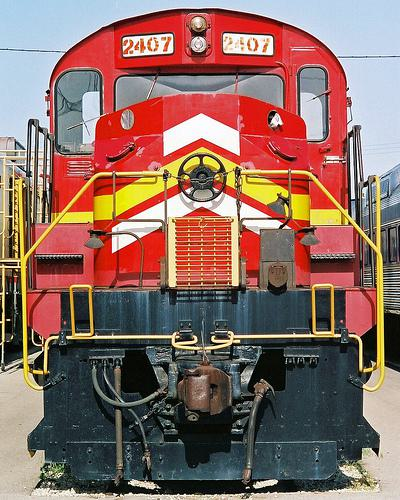Can you describe the color scheme of the train? The train features a striking color scheme of red and yellow. The red is rich and covers the majority of the engine, while the yellow accents appear vividly around the headlights, number plaque, and other areas, enhancing its visibility and aesthetic appeal. 